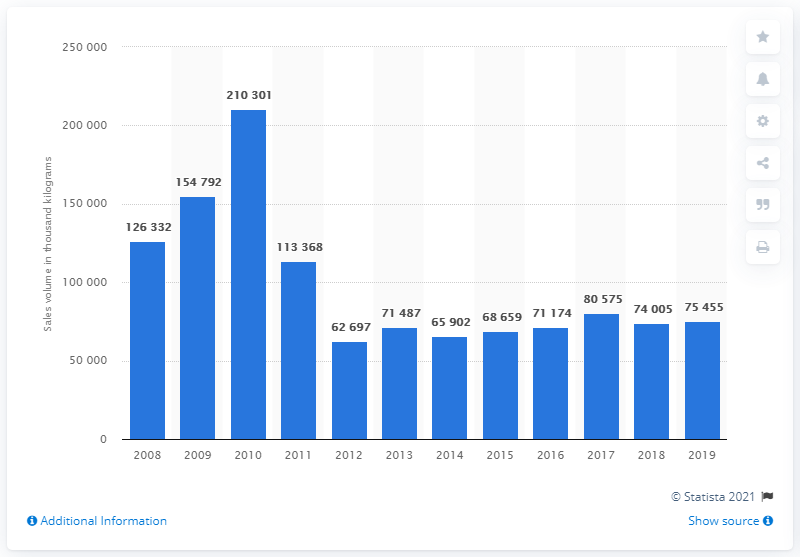Mention a couple of crucial points in this snapshot. In 2019, the sales volume for vegetables, fruit, and nuts was 75,455. The total manufacturing sales volume for vegetables, fruit, and nuts in the UK was in 2008. 